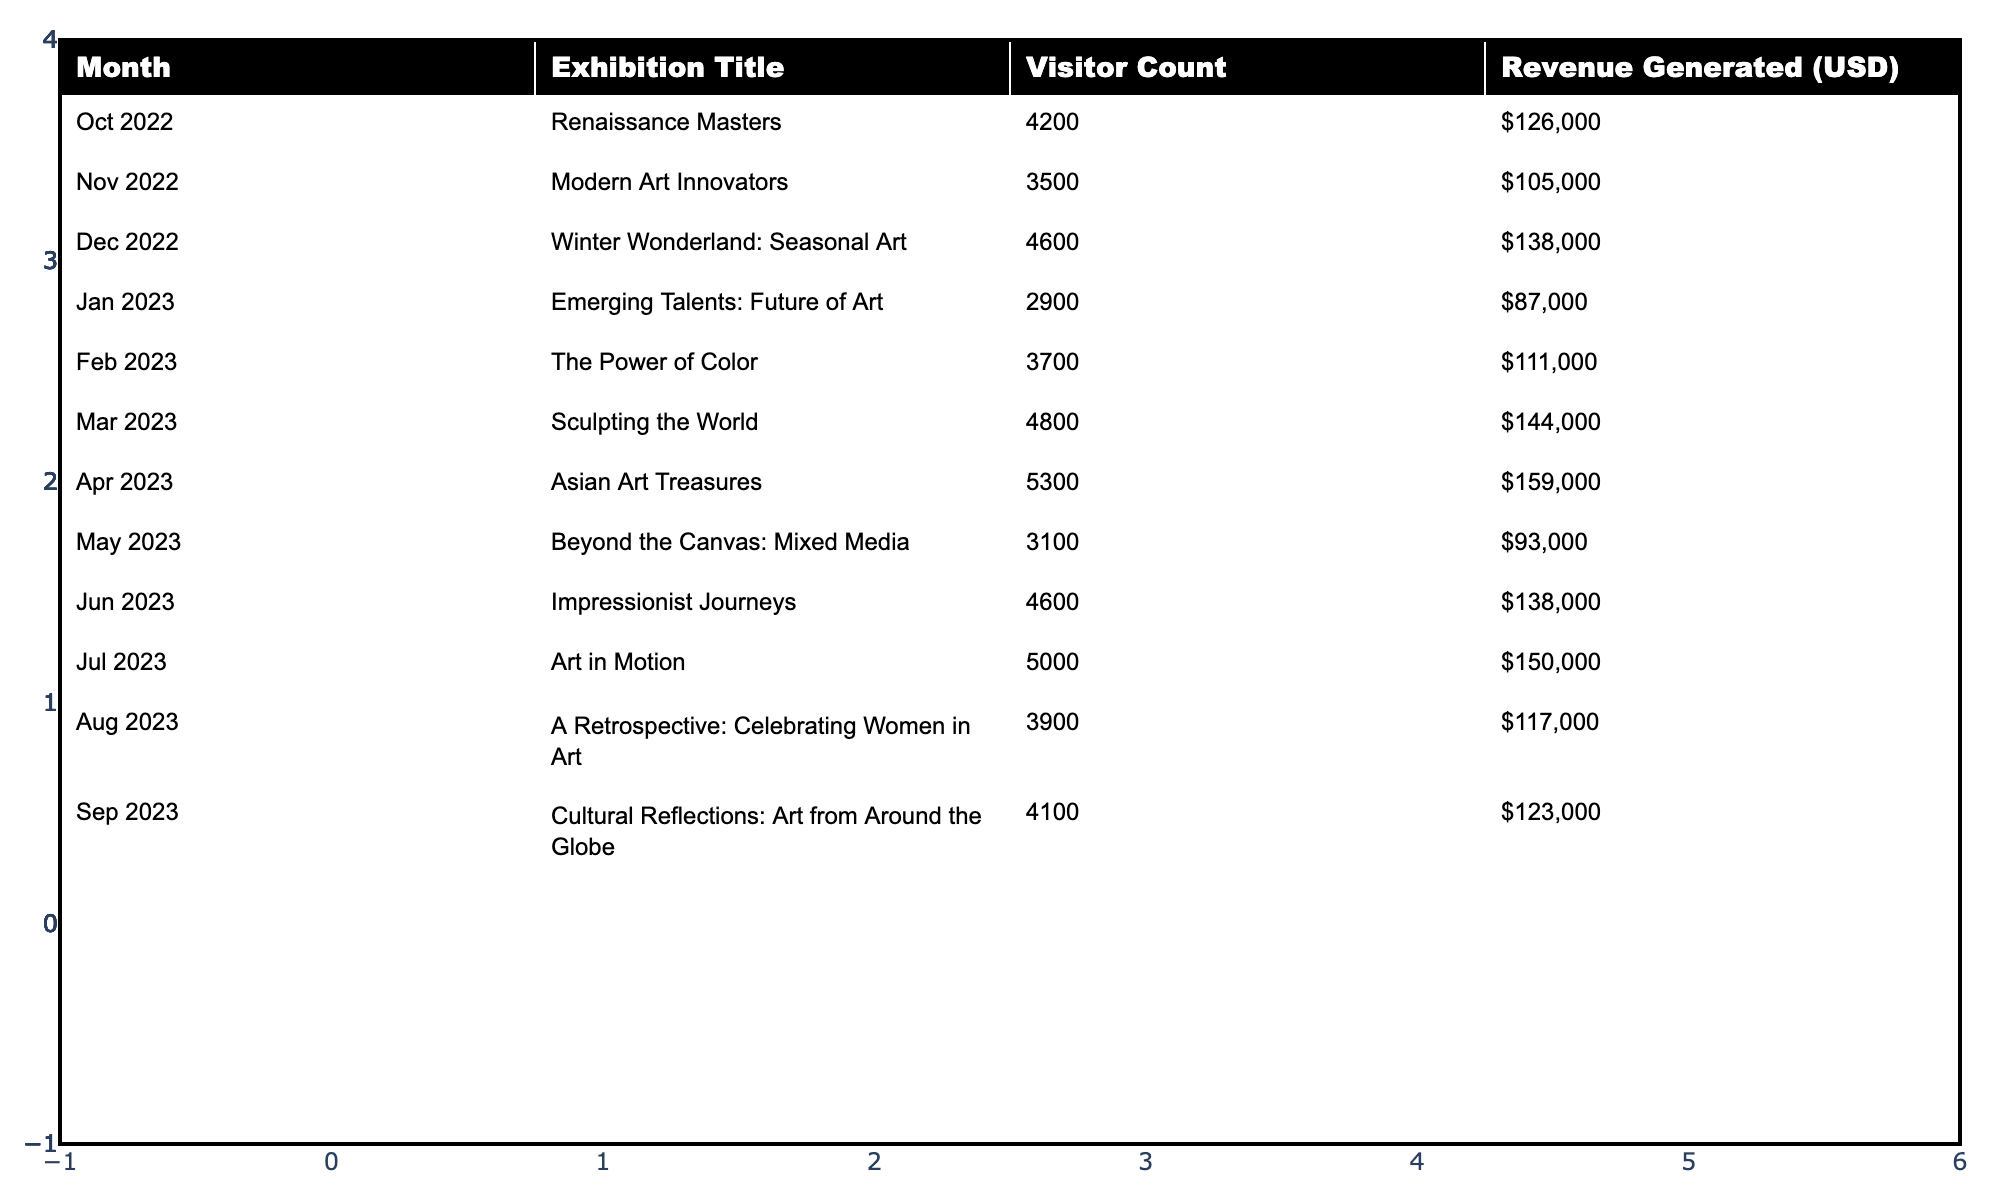What was the visitor count for the exhibition titled "Asian Art Treasures"? The visitor count for "Asian Art Treasures," held in April 2023, can be found directly in the table. It states that the visitor count was 5300.
Answer: 5300 Which month had the highest revenue generated? To find the month with the highest revenue, we compare the values listed under the "Revenue Generated (USD)" column. April 2023 had the highest revenue at $159,000.
Answer: April 2023 What is the total visitor count for the exhibitions from June to September 2023? We need to sum the visitor counts from June (4600), July (5000), August (3900), and September (4100). The total is 4600 + 5000 + 3900 + 4100 = 22600.
Answer: 22600 How many visitors attended the exhibition "Emerging Talents: Future of Art"? The visitor count for "Emerging Talents: Future of Art," which took place in January 2023, is listed in the table as 2900.
Answer: 2900 Was the average visitor count for the exhibitions in the second half of 2023 (July to September) greater than the average for the first half (October to March)? To find this, we first calculate the average visitor count for each half. For the second half, we sum July (5000), August (3900), and September (4100) which equals 13000, divided by 3 gives approximately 4333.33. For the first half, we sum October (4200), November (3500), December (4600), January (2900), February (3700), March (4800) which equals 26700, divided by 6 gives 4450. The average for the first half (4450) is greater than that for the second half (4333.33).
Answer: No Which exhibition had the lowest number of visitors, and what was that count? By reviewing the "Visitor Count" column, we can identify the exhibition with the lowest attendance. "Emerging Talents: Future of Art" had the lowest count at 2900 visitors.
Answer: "Emerging Talents: Future of Art", 2900 What is the difference in visitor count between the highest-attended exhibition and the lowest-attended exhibition? The highest-attended exhibition is "Asian Art Treasures" with 5300 visitors. The lowest is "Emerging Talents: Future of Art" with 2900 visitors. The difference is 5300 - 2900 = 2400.
Answer: 2400 Which month had a visitor count of 3700? According to the table, February 2023 had a visitor count of 3700 for the exhibition "The Power of Color."
Answer: February 2023 What is the total revenue generated from all exhibitions held in 2022? To find this, we sum the revenues for the exhibitions in 2022: October ($126,000), November ($105,000), and December ($138,000). The total revenue is 126,000 + 105,000 + 138,000 = $369,000.
Answer: $369,000 Were there more exhibitions with visitor counts over 4000 or under 4000? By reviewing the table, we count the exhibitions: Six had over 4000 visitors (all except "Modern Art Innovators" and "Beyond the Canvas: Mixed Media"), hence there are more exhibitions with visitor counts over 4000.
Answer: Yes What was the total visitor count at the museum over the entire year? We will sum the visitor counts of all exhibitions for the entire year. That sums as follows: 4200 + 3500 + 4600 + 2900 + 3700 + 4800 + 5300 + 3100 + 4600 + 5000 + 3900 + 4100 =  52300.
Answer: 52300 